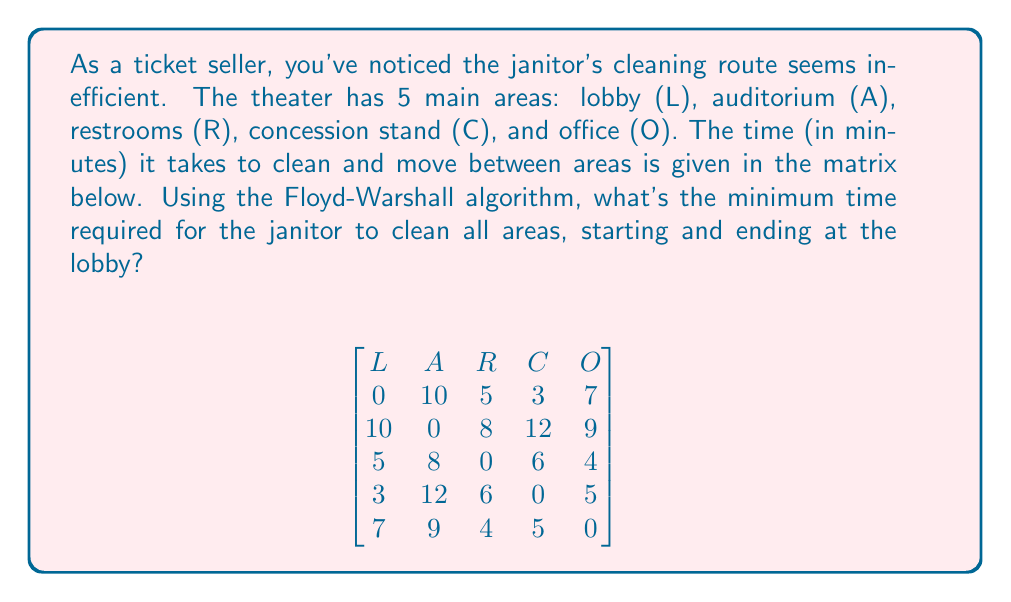Solve this math problem. To solve this problem, we'll use the Floyd-Warshall algorithm to find the shortest paths between all pairs of vertices, then apply the Held-Karp algorithm to solve the resulting Traveling Salesman Problem (TSP).

Step 1: Apply Floyd-Warshall algorithm
The given matrix already represents the shortest paths between directly connected vertices. We don't need to modify it.

Step 2: Solve the TSP using Held-Karp algorithm
Let's define $C(S, i)$ as the cost of the shortest path visiting each vertex in set $S$ exactly once, starting at L and ending at vertex $i$.

Base case: $C(\{i\}, i) = \text{matrix}[L][i]$ for $i \neq L$

Recursive case: $C(S, i) = \min_{j \in S, j \neq i} \{C(S - \{i\}, j) + \text{matrix}[j][i]\}$

We compute this for all subsets $S$ of $\{A, R, C, O\}$ and all $i \in S$.

Final solution: $\min_{i \neq L} \{C(\{A, R, C, O\}, i) + \text{matrix}[i][L]\}$

Calculations:
$C(\{A\}, A) = 10$
$C(\{R\}, R) = 5$
$C(\{C\}, C) = 3$
$C(\{O\}, O) = 7$

$C(\{A,R\}, A) = \min(5 + 8) = 13$
$C(\{A,R\}, R) = \min(10 + 8) = 18$
$C(\{A,C\}, A) = \min(3 + 12) = 15$
$C(\{A,C\}, C) = \min(10 + 12) = 22$
$C(\{A,O\}, A) = \min(7 + 9) = 16$
$C(\{A,O\}, O) = \min(10 + 9) = 19$
$C(\{R,C\}, R) = \min(3 + 6) = 9$
$C(\{R,C\}, C) = \min(5 + 6) = 11$
$C(\{R,O\}, R) = \min(7 + 4) = 11$
$C(\{R,O\}, O) = \min(5 + 4) = 9$
$C(\{C,O\}, C) = \min(7 + 5) = 12$
$C(\{C,O\}, O) = \min(3 + 5) = 8$

$C(\{A,R,C\}, A) = \min(9 + 8, 11 + 12) = 17$
$C(\{A,R,C\}, R) = \min(15 + 8, 22 + 6) = 23$
$C(\{A,R,C\}, C) = \min(13 + 12, 18 + 6) = 24$
$C(\{A,R,O\}, A) = \min(11 + 9, 9 + 9) = 18$
$C(\{A,R,O\}, R) = \min(16 + 8, 19 + 4) = 23$
$C(\{A,R,O\}, O) = \min(13 + 9, 18 + 4) = 22$
$C(\{A,C,O\}, A) = \min(12 + 12, 8 + 9) = 17$
$C(\{A,C,O\}, C) = \min(16 + 12, 19 + 5) = 24$
$C(\{A,C,O\}, O) = \min(15 + 9, 22 + 5) = 24$
$C(\{R,C,O\}, R) = \min(12 + 6, 8 + 4) = 12$
$C(\{R,C,O\}, C) = \min(11 + 6, 9 + 5) = 14$
$C(\{R,C,O\}, O) = \min(9 + 5, 11 + 4) = 14$

$C(\{A,R,C,O\}, A) = \min(12 + 8, 14 + 12, 14 + 9) = 20$
$C(\{A,R,C,O\}, R) = \min(17 + 8, 24 + 6, 24 + 4) = 25$
$C(\{A,R,C,O\}, C) = \min(18 + 12, 23 + 6, 22 + 5) = 27$
$C(\{A,R,C,O\}, O) = \min(17 + 9, 23 + 4, 24 + 5) = 26$

Final solution:
$\min(20 + 10, 25 + 5, 27 + 3, 26 + 7) = \min(30, 30, 30, 33) = 30$
Answer: 30 minutes 